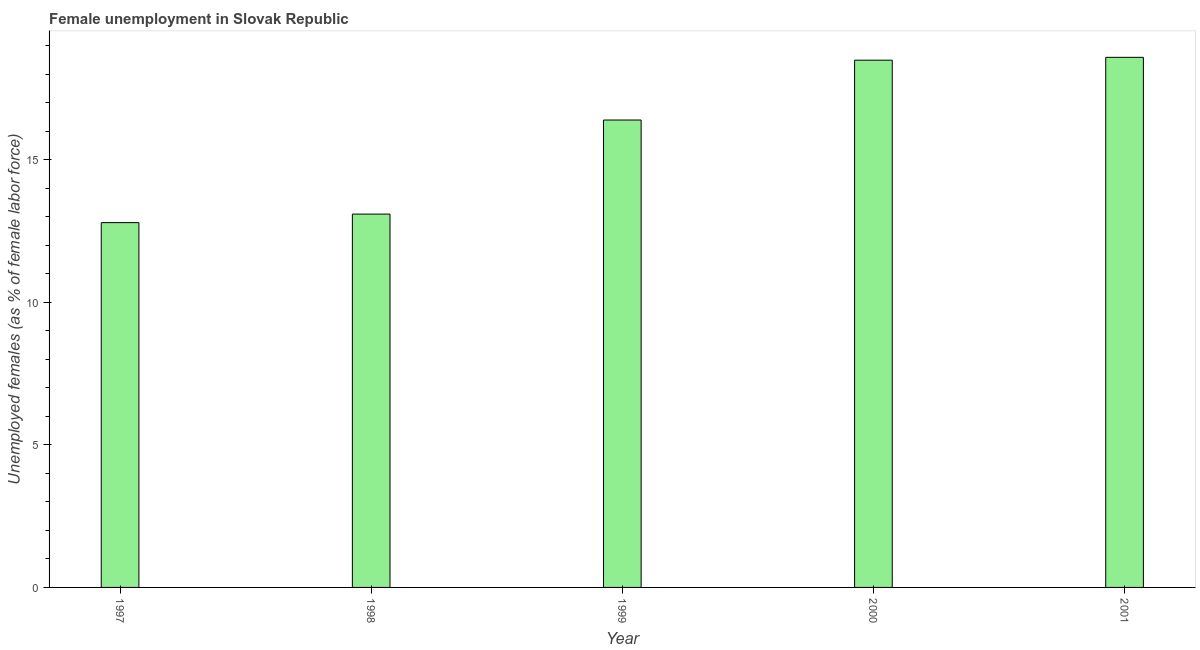Does the graph contain any zero values?
Your answer should be compact. No. What is the title of the graph?
Give a very brief answer. Female unemployment in Slovak Republic. What is the label or title of the X-axis?
Offer a very short reply. Year. What is the label or title of the Y-axis?
Offer a terse response. Unemployed females (as % of female labor force). What is the unemployed females population in 1998?
Make the answer very short. 13.1. Across all years, what is the maximum unemployed females population?
Make the answer very short. 18.6. Across all years, what is the minimum unemployed females population?
Your answer should be compact. 12.8. What is the sum of the unemployed females population?
Make the answer very short. 79.4. What is the difference between the unemployed females population in 1999 and 2001?
Your response must be concise. -2.2. What is the average unemployed females population per year?
Provide a succinct answer. 15.88. What is the median unemployed females population?
Make the answer very short. 16.4. In how many years, is the unemployed females population greater than 7 %?
Your answer should be very brief. 5. Do a majority of the years between 1998 and 1997 (inclusive) have unemployed females population greater than 5 %?
Keep it short and to the point. No. What is the ratio of the unemployed females population in 1997 to that in 1998?
Give a very brief answer. 0.98. Is the unemployed females population in 1997 less than that in 2000?
Give a very brief answer. Yes. What is the difference between the highest and the second highest unemployed females population?
Provide a succinct answer. 0.1. Is the sum of the unemployed females population in 1997 and 2001 greater than the maximum unemployed females population across all years?
Give a very brief answer. Yes. What is the difference between the highest and the lowest unemployed females population?
Ensure brevity in your answer.  5.8. Are all the bars in the graph horizontal?
Offer a terse response. No. How many years are there in the graph?
Keep it short and to the point. 5. What is the Unemployed females (as % of female labor force) in 1997?
Make the answer very short. 12.8. What is the Unemployed females (as % of female labor force) of 1998?
Your answer should be very brief. 13.1. What is the Unemployed females (as % of female labor force) in 1999?
Keep it short and to the point. 16.4. What is the Unemployed females (as % of female labor force) in 2001?
Make the answer very short. 18.6. What is the difference between the Unemployed females (as % of female labor force) in 1997 and 1998?
Offer a terse response. -0.3. What is the difference between the Unemployed females (as % of female labor force) in 1997 and 2001?
Your answer should be compact. -5.8. What is the difference between the Unemployed females (as % of female labor force) in 1998 and 2000?
Provide a succinct answer. -5.4. What is the difference between the Unemployed females (as % of female labor force) in 1998 and 2001?
Offer a terse response. -5.5. What is the difference between the Unemployed females (as % of female labor force) in 1999 and 2000?
Keep it short and to the point. -2.1. What is the difference between the Unemployed females (as % of female labor force) in 1999 and 2001?
Your answer should be very brief. -2.2. What is the ratio of the Unemployed females (as % of female labor force) in 1997 to that in 1999?
Your answer should be compact. 0.78. What is the ratio of the Unemployed females (as % of female labor force) in 1997 to that in 2000?
Your response must be concise. 0.69. What is the ratio of the Unemployed females (as % of female labor force) in 1997 to that in 2001?
Offer a terse response. 0.69. What is the ratio of the Unemployed females (as % of female labor force) in 1998 to that in 1999?
Ensure brevity in your answer.  0.8. What is the ratio of the Unemployed females (as % of female labor force) in 1998 to that in 2000?
Provide a succinct answer. 0.71. What is the ratio of the Unemployed females (as % of female labor force) in 1998 to that in 2001?
Offer a terse response. 0.7. What is the ratio of the Unemployed females (as % of female labor force) in 1999 to that in 2000?
Keep it short and to the point. 0.89. What is the ratio of the Unemployed females (as % of female labor force) in 1999 to that in 2001?
Provide a short and direct response. 0.88. What is the ratio of the Unemployed females (as % of female labor force) in 2000 to that in 2001?
Ensure brevity in your answer.  0.99. 